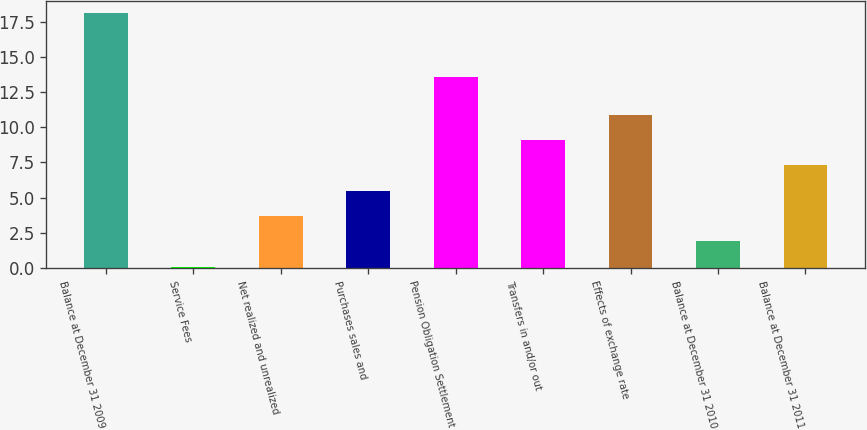Convert chart. <chart><loc_0><loc_0><loc_500><loc_500><bar_chart><fcel>Balance at December 31 2009<fcel>Service Fees<fcel>Net realized and unrealized<fcel>Purchases sales and<fcel>Pension Obligation Settlement<fcel>Transfers in and/or out<fcel>Effects of exchange rate<fcel>Balance at December 31 2010<fcel>Balance at December 31 2011<nl><fcel>18.1<fcel>0.1<fcel>3.7<fcel>5.5<fcel>13.6<fcel>9.1<fcel>10.9<fcel>1.9<fcel>7.3<nl></chart> 